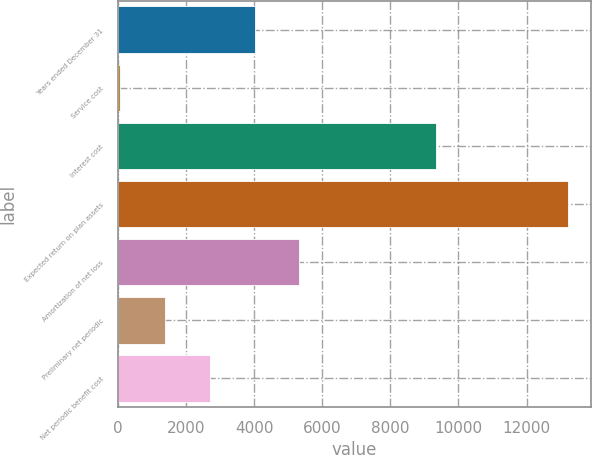<chart> <loc_0><loc_0><loc_500><loc_500><bar_chart><fcel>Years ended December 31<fcel>Service cost<fcel>Interest cost<fcel>Expected return on plan assets<fcel>Amortization of net loss<fcel>Preliminary net periodic<fcel>Net periodic benefit cost<nl><fcel>4015.4<fcel>71<fcel>9331<fcel>13219<fcel>5330.2<fcel>1385.8<fcel>2700.6<nl></chart> 